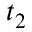Convert formula to latex. <formula><loc_0><loc_0><loc_500><loc_500>t _ { 2 }</formula> 